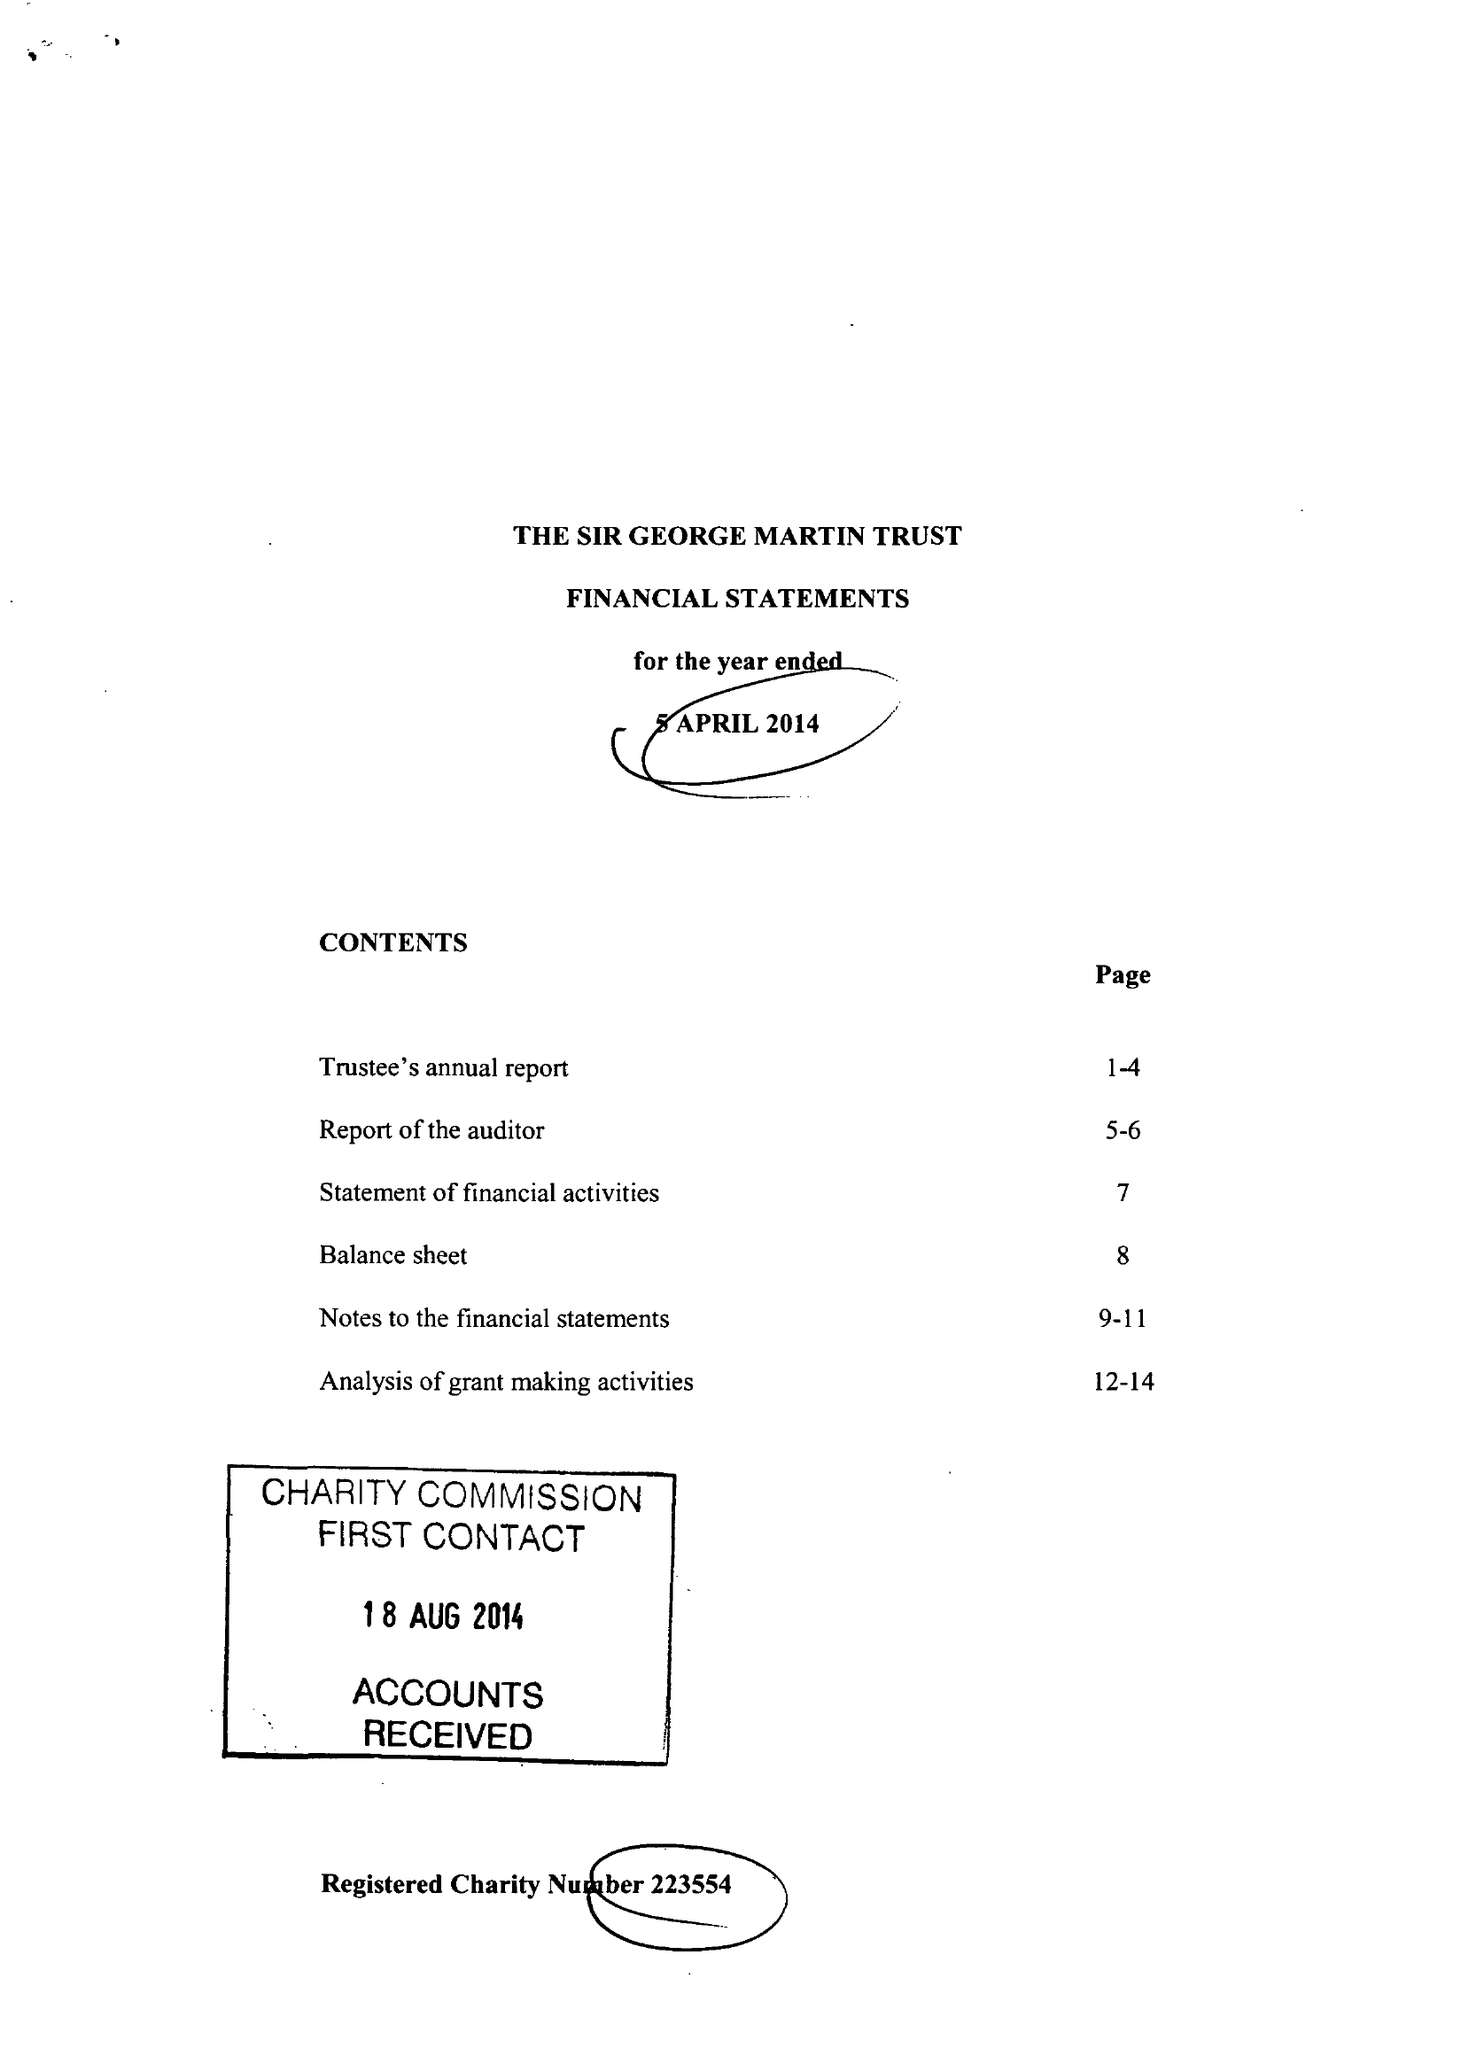What is the value for the address__postcode?
Answer the question using a single word or phrase. HG2 9HA 